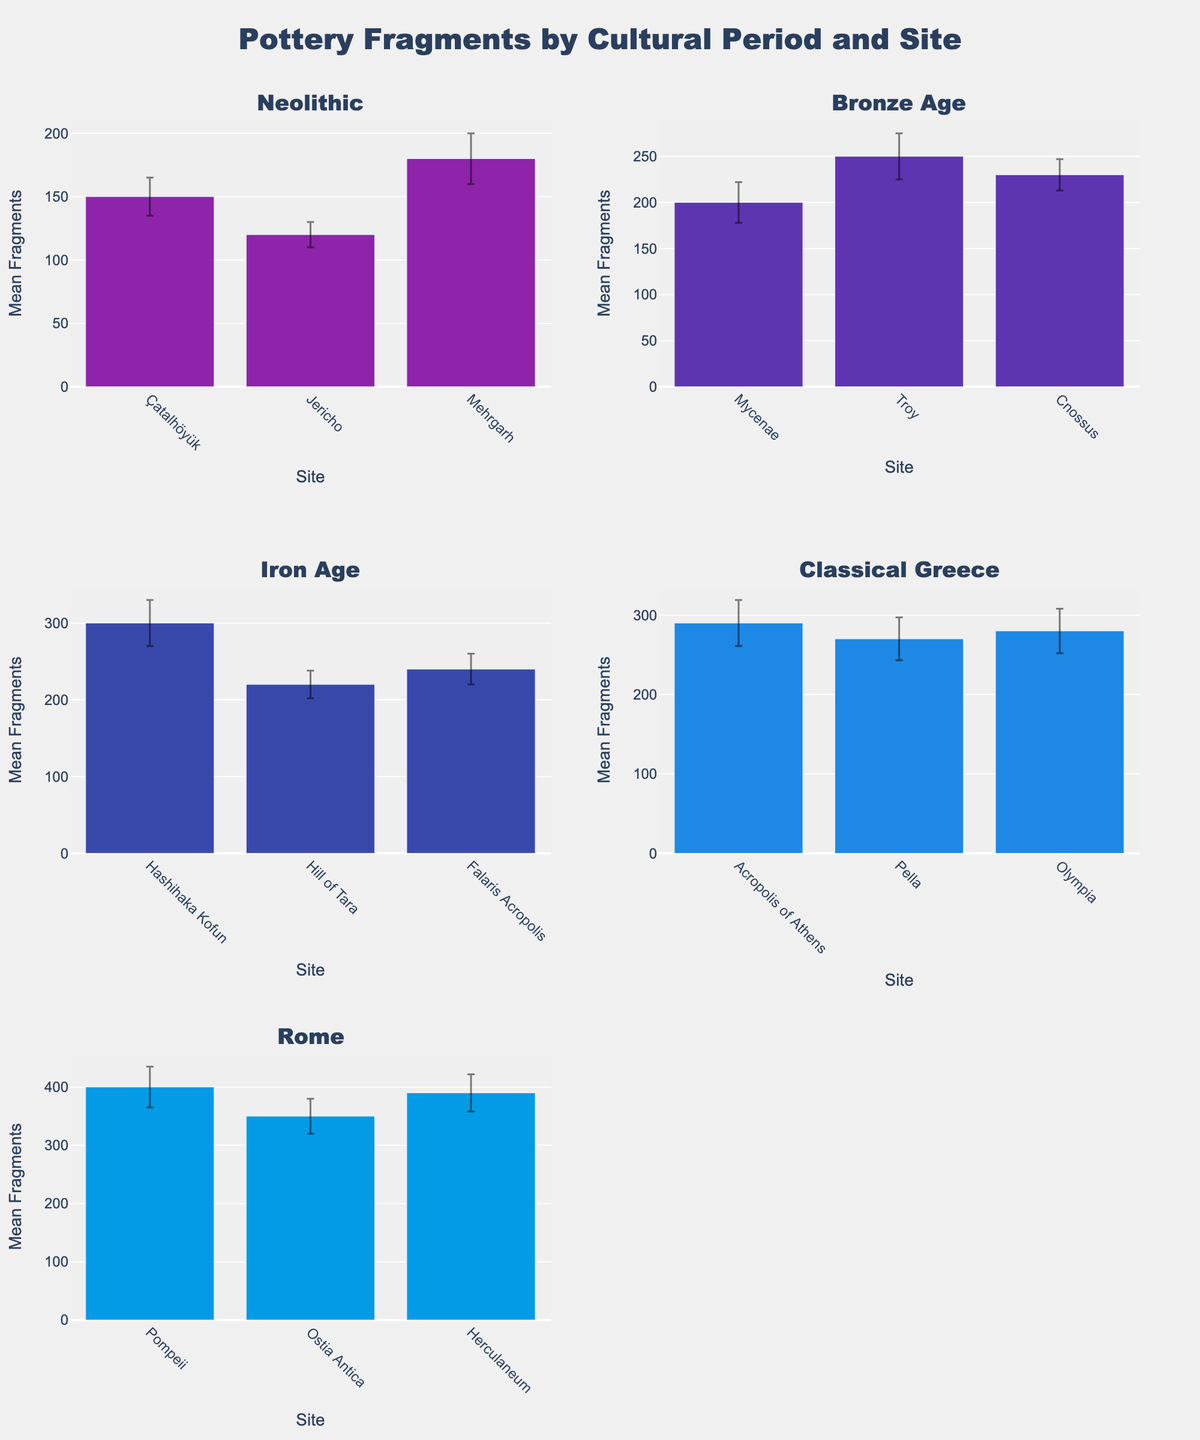What is the title of the figure? The title of the figure is usually located at the top center. The figure clearly displays 'Pottery Fragments by Cultural Period and Site' as its title.
Answer: Pottery Fragments by Cultural Period and Site Which site in the Rome period has the highest mean fragments? The figure shows the mean fragments for different sites within the Rome period in a bar plot. Pompeii has the highest mean fragments as its bar is the tallest among the sites in the Rome period subplot.
Answer: Pompeii How many cultural periods are depicted in the subplots? The subplot titles indicate the different cultural periods. Counting the unique subplot titles gives us the number of cultural periods. There are five cultural periods represented.
Answer: 5 What is the mean fragment value for Troy during the Bronze Age? Focusing on the Bronze Age subplot and locating Troy's bar, the bar height gives the mean fragment value. The mean fragments for Troy is 250.
Answer: 250 Which cultural period has the site with the lowest mean fragments, and which site is it? Looking across all subplots, identify the shortest bar. The Neolithic period at Jericho has the shortest bar, representing the lowest mean fragments.
Answer: Neolithic, Jericho How much higher is the mean fragment count at the Acropolis of Athens compared to Falaris Acropolis? Locate and compare the heights of the bars for Acropolis of Athens in Classical Greece and Falaris Acropolis in Iron Age. The difference is 290 - 240.
Answer: 50 Which period has the highest average mean fragments across all its sites? For each period, calculate the average mean fragments by summing the means and dividing by the number of sites. Compare these averages to find the highest one. Rome has the highest average mean fragments because (400 + 350 + 390) / 3 = 380 is the largest average.
Answer: Rome What is the combined mean fragment count for all sites in the Iron Age? Add the mean fragments for all sites in the Iron Age subplot: Hashihaka Kofun, Hill of Tara, and Falaris Acropolis. The sum is 300 + 220 + 240.
Answer: 760 Which site has the highest standard error, and how much is it? Locate the error bars and identify the longest one. Pompeii in the Rome period has the longest error bar with a standard error of 35.
Answer: Pompeii, 35 Which period has the highest variation in mean fragments between sites, and how do you determine that? Calculate the range (max - min) of mean fragments for each period and compare these values. The period with the highest range indicates the highest variation. For Rome: 400 - 350 = 50; for Neolithic: 180 - 120 = 60; and so forth. The Iron Age has the highest variation with 300 - 220 = 80.
Answer: Iron Age 